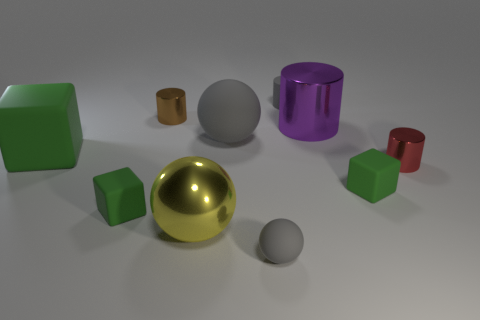How many objects are either metallic cylinders in front of the big green cube or gray objects?
Provide a succinct answer. 4. What is the color of the ball that is the same size as the brown object?
Make the answer very short. Gray. Are there more objects that are behind the large gray ball than large matte blocks?
Offer a very short reply. Yes. There is a gray thing that is in front of the tiny brown metal cylinder and on the right side of the big gray object; what material is it?
Your answer should be very brief. Rubber. There is a small cube on the left side of the gray cylinder; is it the same color as the big cube on the left side of the large gray ball?
Ensure brevity in your answer.  Yes. How many other things are the same size as the red metallic cylinder?
Make the answer very short. 5. Are there any large spheres behind the green cube that is right of the tiny cube to the left of the tiny ball?
Ensure brevity in your answer.  Yes. Does the small cylinder in front of the tiny brown metallic cylinder have the same material as the big purple object?
Provide a succinct answer. Yes. What color is the other large object that is the same shape as the yellow object?
Ensure brevity in your answer.  Gray. Are there an equal number of big matte objects on the left side of the brown shiny thing and red metal balls?
Keep it short and to the point. No. 